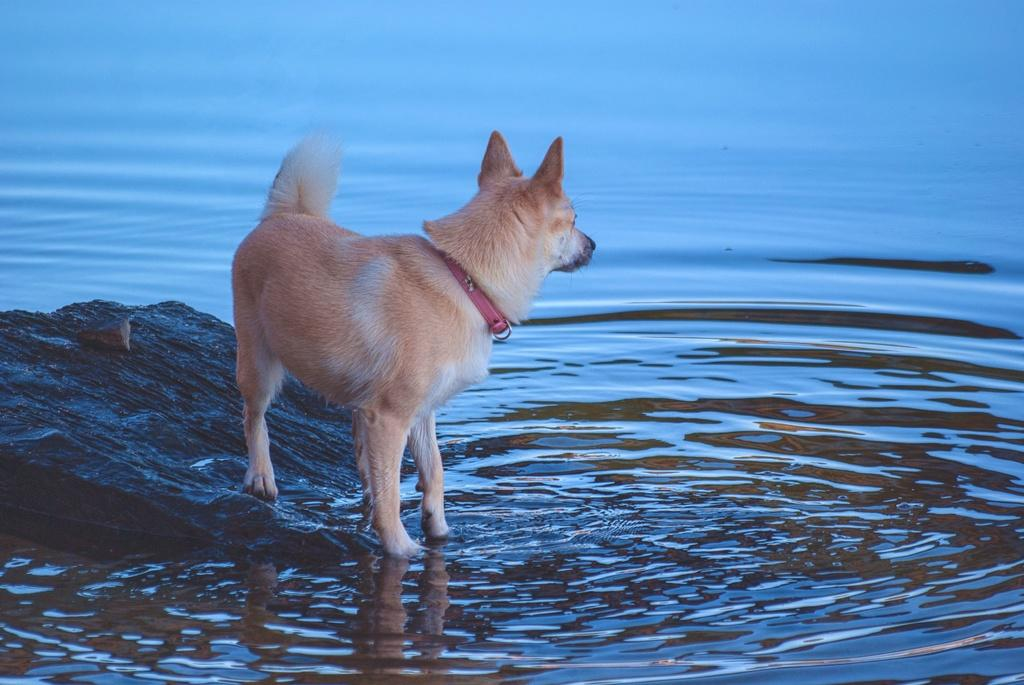What type of animal is present in the image? There is a dog in the image. What is visible in the background of the image? Water is visible in the image. What other object can be seen in the image? There is a rock in the image. What type of apparel is the dog wearing in the image? There is no apparel visible on the dog in the image. 